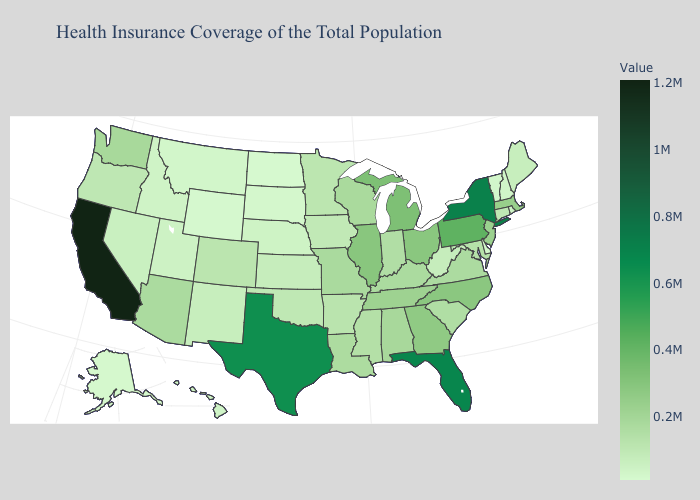Does New Hampshire have the highest value in the Northeast?
Be succinct. No. Is the legend a continuous bar?
Be succinct. Yes. Does Vermont have the lowest value in the Northeast?
Keep it brief. Yes. Does North Dakota have the lowest value in the USA?
Write a very short answer. Yes. 